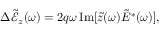<formula> <loc_0><loc_0><loc_500><loc_500>\Delta \tilde { \mathcal { E } } _ { z } ( \omega ) = 2 q \omega \, I m [ \tilde { z } ( \omega ) \tilde { E } ^ { * } ( \omega ) ] ,</formula> 